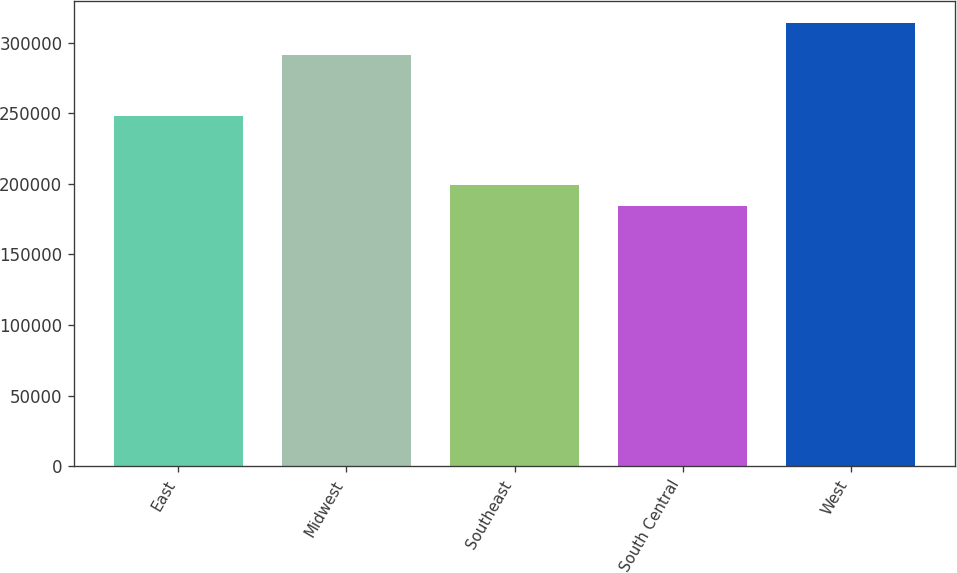Convert chart. <chart><loc_0><loc_0><loc_500><loc_500><bar_chart><fcel>East<fcel>Midwest<fcel>Southeast<fcel>South Central<fcel>West<nl><fcel>248000<fcel>291500<fcel>198800<fcel>183900<fcel>314000<nl></chart> 